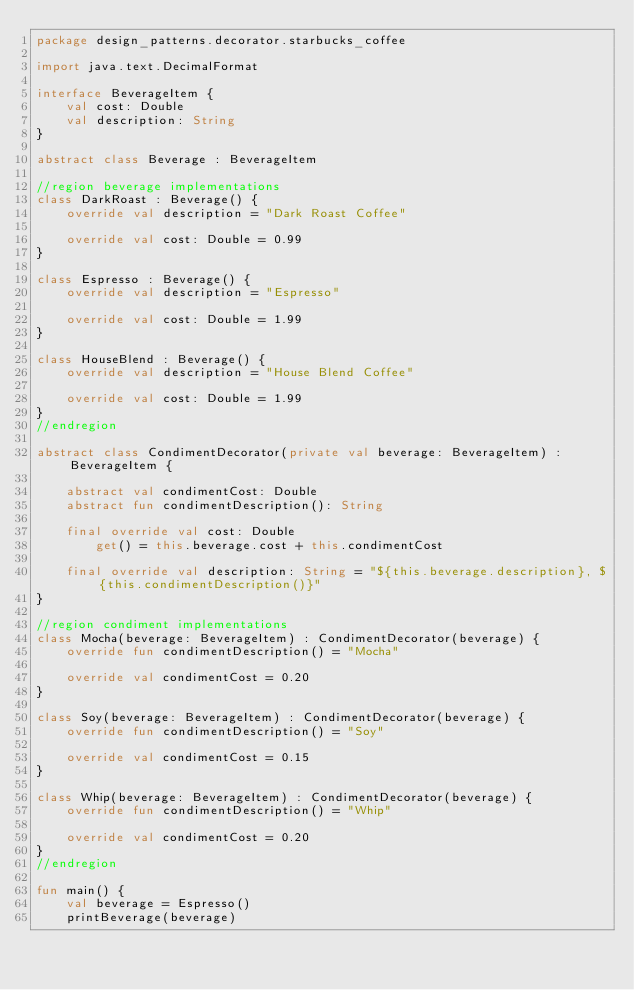<code> <loc_0><loc_0><loc_500><loc_500><_Kotlin_>package design_patterns.decorator.starbucks_coffee

import java.text.DecimalFormat

interface BeverageItem {
    val cost: Double
    val description: String
}

abstract class Beverage : BeverageItem

//region beverage implementations
class DarkRoast : Beverage() {
    override val description = "Dark Roast Coffee"

    override val cost: Double = 0.99
}

class Espresso : Beverage() {
    override val description = "Espresso"

    override val cost: Double = 1.99
}

class HouseBlend : Beverage() {
    override val description = "House Blend Coffee"

    override val cost: Double = 1.99
}
//endregion

abstract class CondimentDecorator(private val beverage: BeverageItem) : BeverageItem {

    abstract val condimentCost: Double
    abstract fun condimentDescription(): String

    final override val cost: Double
        get() = this.beverage.cost + this.condimentCost

    final override val description: String = "${this.beverage.description}, ${this.condimentDescription()}"
}

//region condiment implementations
class Mocha(beverage: BeverageItem) : CondimentDecorator(beverage) {
    override fun condimentDescription() = "Mocha"

    override val condimentCost = 0.20
}

class Soy(beverage: BeverageItem) : CondimentDecorator(beverage) {
    override fun condimentDescription() = "Soy"

    override val condimentCost = 0.15
}

class Whip(beverage: BeverageItem) : CondimentDecorator(beverage) {
    override fun condimentDescription() = "Whip"

    override val condimentCost = 0.20
}
//endregion

fun main() {
    val beverage = Espresso()
    printBeverage(beverage)
</code> 